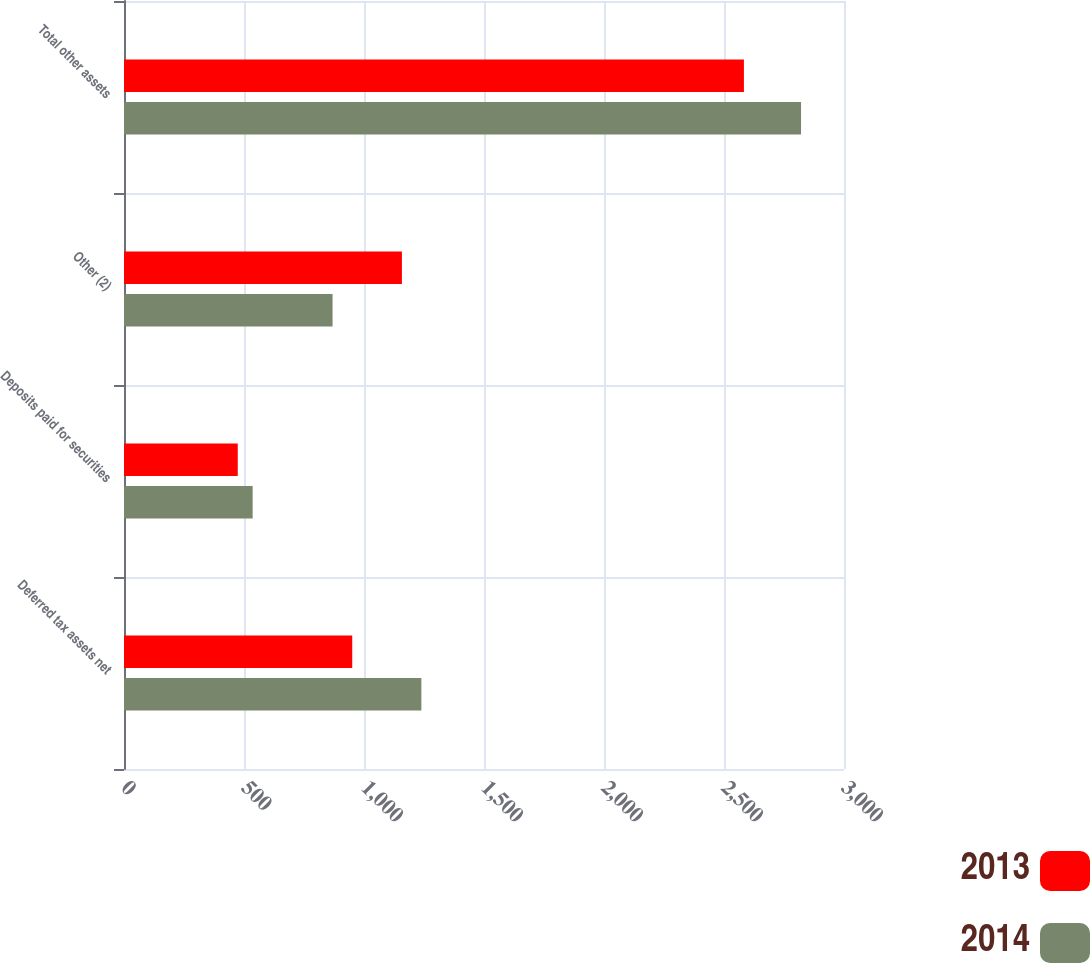Convert chart. <chart><loc_0><loc_0><loc_500><loc_500><stacked_bar_chart><ecel><fcel>Deferred tax assets net<fcel>Deposits paid for securities<fcel>Other (2)<fcel>Total other assets<nl><fcel>2013<fcel>951<fcel>474<fcel>1158<fcel>2583<nl><fcel>2014<fcel>1239<fcel>536<fcel>869<fcel>2821<nl></chart> 